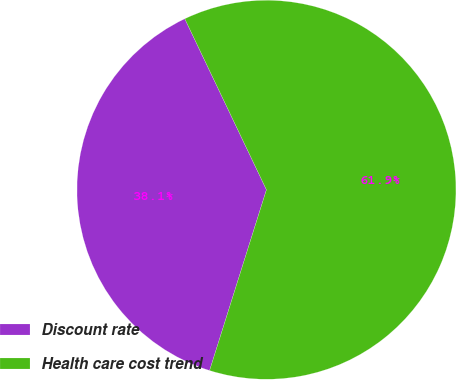Convert chart to OTSL. <chart><loc_0><loc_0><loc_500><loc_500><pie_chart><fcel>Discount rate<fcel>Health care cost trend<nl><fcel>38.06%<fcel>61.94%<nl></chart> 